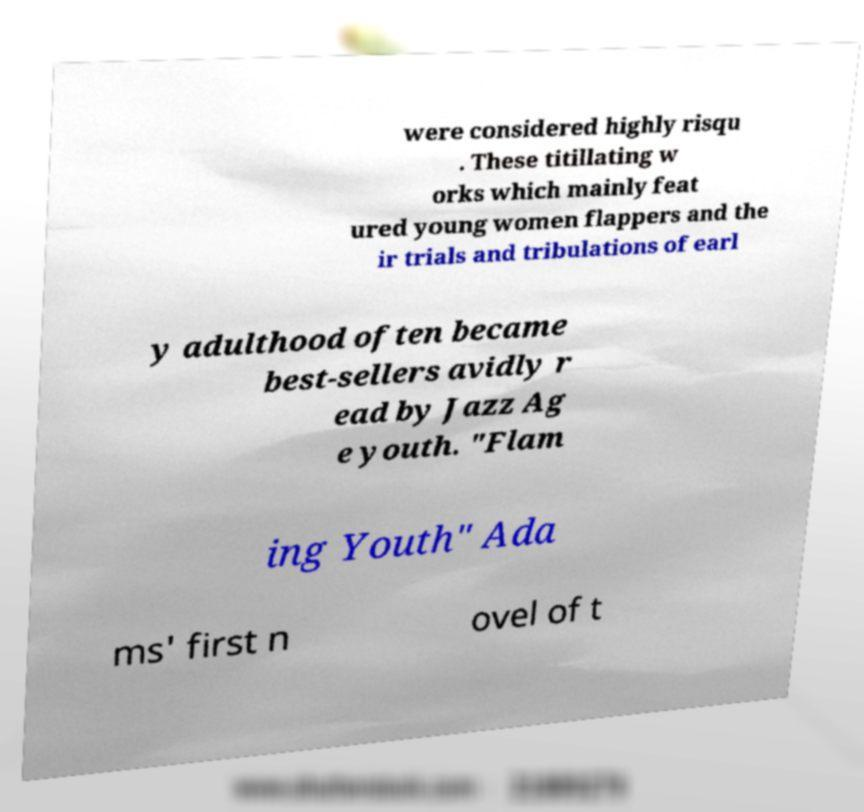Could you extract and type out the text from this image? were considered highly risqu . These titillating w orks which mainly feat ured young women flappers and the ir trials and tribulations of earl y adulthood often became best-sellers avidly r ead by Jazz Ag e youth. "Flam ing Youth" Ada ms' first n ovel of t 